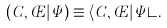<formula> <loc_0><loc_0><loc_500><loc_500>( { C , \phi } | \Psi ) \equiv \langle { C , \phi } | \Psi \rangle .</formula> 